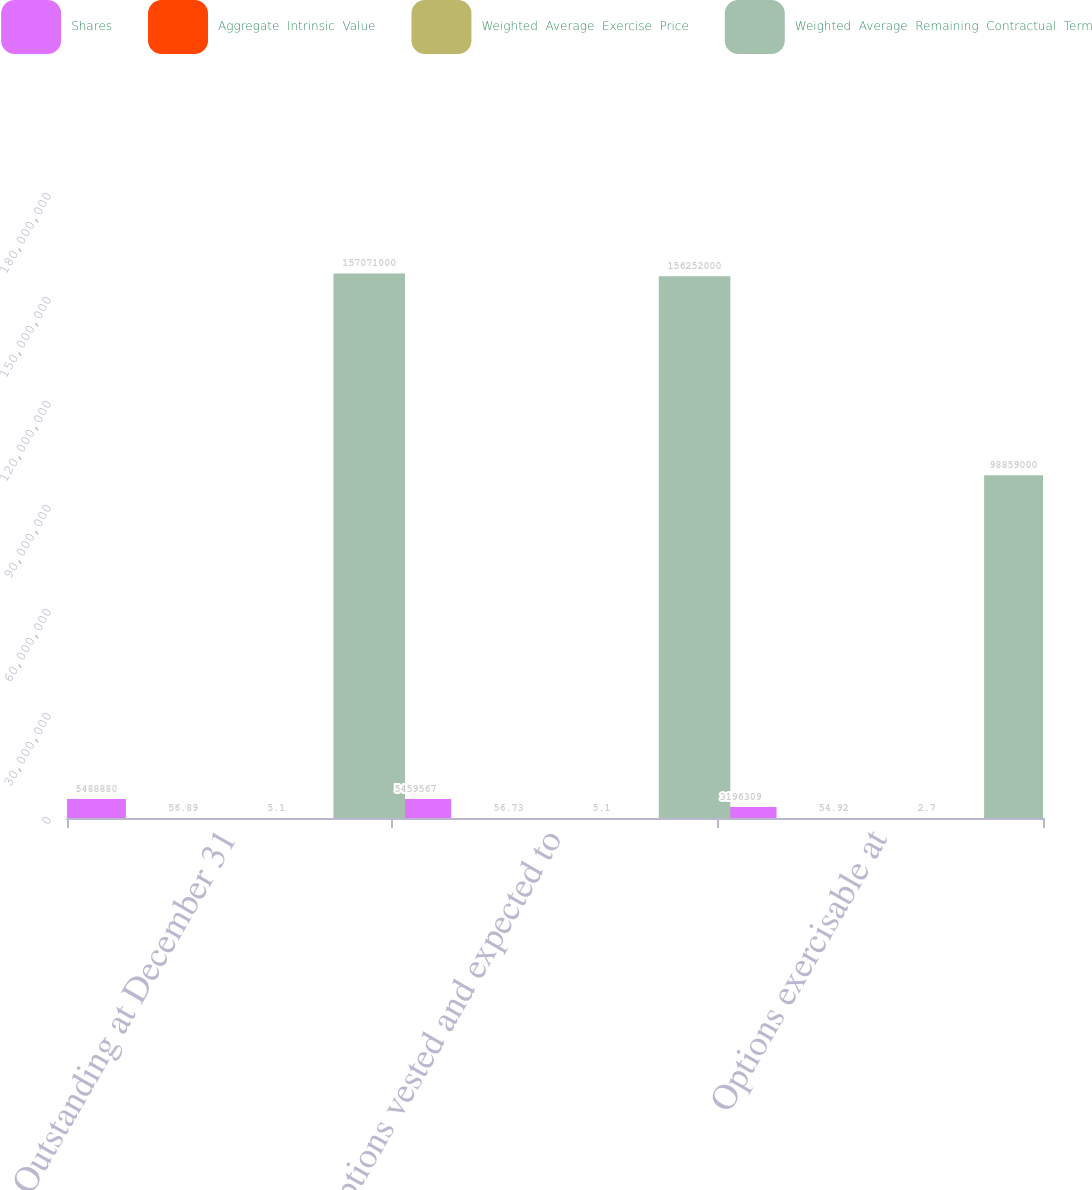Convert chart to OTSL. <chart><loc_0><loc_0><loc_500><loc_500><stacked_bar_chart><ecel><fcel>Outstanding at December 31<fcel>Options vested and expected to<fcel>Options exercisable at<nl><fcel>Shares<fcel>5.48888e+06<fcel>5.45957e+06<fcel>3.19631e+06<nl><fcel>Aggregate  Intrinsic  Value<fcel>56.89<fcel>56.73<fcel>54.92<nl><fcel>Weighted  Average  Exercise  Price<fcel>5.1<fcel>5.1<fcel>2.7<nl><fcel>Weighted  Average  Remaining  Contractual  Term<fcel>1.57071e+08<fcel>1.56252e+08<fcel>9.8859e+07<nl></chart> 